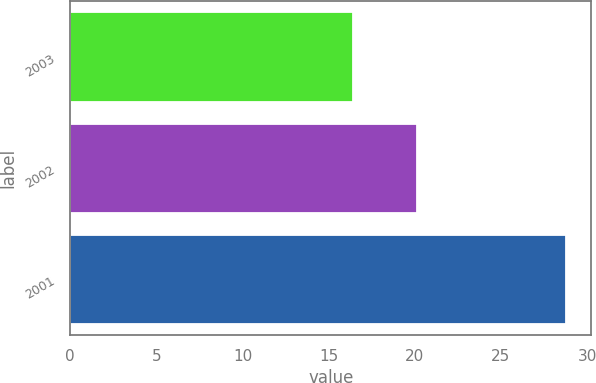<chart> <loc_0><loc_0><loc_500><loc_500><bar_chart><fcel>2003<fcel>2002<fcel>2001<nl><fcel>16.4<fcel>20.1<fcel>28.8<nl></chart> 